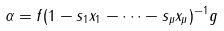<formula> <loc_0><loc_0><loc_500><loc_500>\alpha = f ( 1 - s _ { 1 } x _ { 1 } - \cdots - s _ { \mu } x _ { \mu } ) ^ { - 1 } g</formula> 